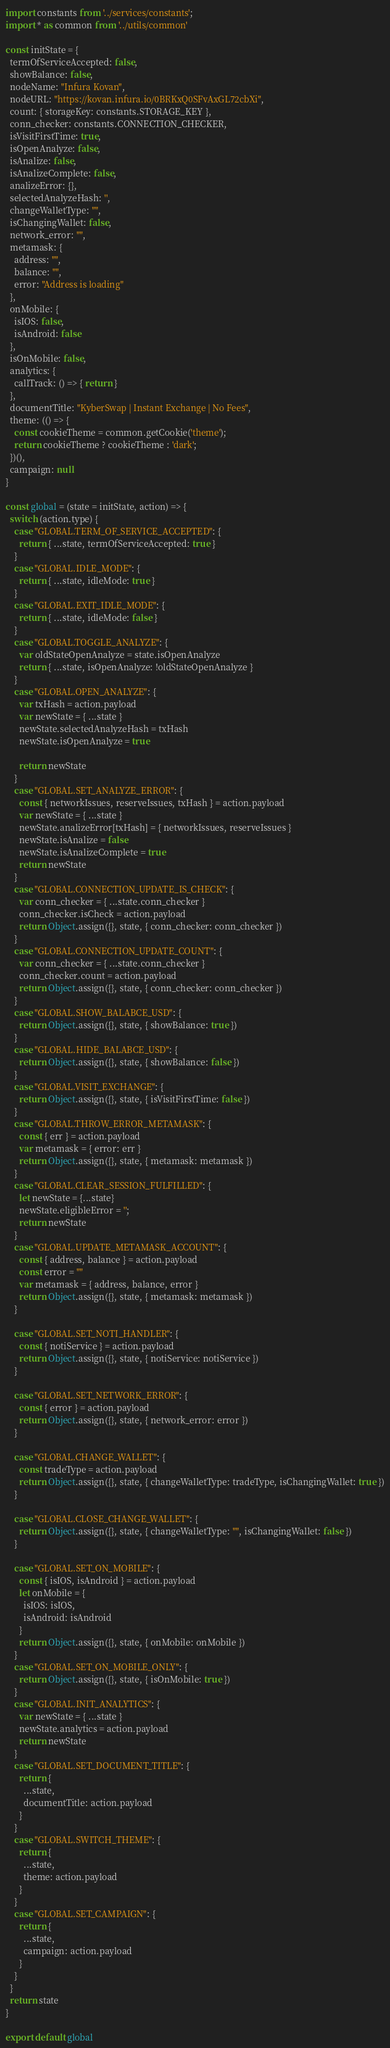<code> <loc_0><loc_0><loc_500><loc_500><_JavaScript_>import constants from '../services/constants';
import * as common from '../utils/common'

const initState = {
  termOfServiceAccepted: false,
  showBalance: false,
  nodeName: "Infura Kovan",
  nodeURL: "https://kovan.infura.io/0BRKxQ0SFvAxGL72cbXi",
  count: { storageKey: constants.STORAGE_KEY },
  conn_checker: constants.CONNECTION_CHECKER,
  isVisitFirstTime: true,
  isOpenAnalyze: false,
  isAnalize: false,
  isAnalizeComplete: false,
  analizeError: {},
  selectedAnalyzeHash: '',
  changeWalletType: "",
  isChangingWallet: false,
  network_error: "",
  metamask: {
    address: "",
    balance: "",
    error: "Address is loading"
  },
  onMobile: {
    isIOS: false,
    isAndroid: false
  },
  isOnMobile: false,
  analytics: {
    callTrack: () => { return }
  },
  documentTitle: "KyberSwap | Instant Exchange | No Fees",
  theme: (() => {
    const cookieTheme = common.getCookie('theme');
    return cookieTheme ? cookieTheme : 'dark';
  })(),
  campaign: null
}

const global = (state = initState, action) => {
  switch (action.type) {
    case "GLOBAL.TERM_OF_SERVICE_ACCEPTED": {
      return { ...state, termOfServiceAccepted: true }
    }
    case "GLOBAL.IDLE_MODE": {
      return { ...state, idleMode: true }
    }
    case "GLOBAL.EXIT_IDLE_MODE": {
      return { ...state, idleMode: false }
    }
    case "GLOBAL.TOGGLE_ANALYZE": {
      var oldStateOpenAnalyze = state.isOpenAnalyze
      return { ...state, isOpenAnalyze: !oldStateOpenAnalyze }
    }
    case "GLOBAL.OPEN_ANALYZE": {
      var txHash = action.payload
      var newState = { ...state }
      newState.selectedAnalyzeHash = txHash
      newState.isOpenAnalyze = true

      return newState
    }
    case "GLOBAL.SET_ANALYZE_ERROR": {
      const { networkIssues, reserveIssues, txHash } = action.payload
      var newState = { ...state }
      newState.analizeError[txHash] = { networkIssues, reserveIssues }
      newState.isAnalize = false
      newState.isAnalizeComplete = true
      return newState
    }
    case "GLOBAL.CONNECTION_UPDATE_IS_CHECK": {
      var conn_checker = { ...state.conn_checker }
      conn_checker.isCheck = action.payload
      return Object.assign({}, state, { conn_checker: conn_checker })
    }
    case "GLOBAL.CONNECTION_UPDATE_COUNT": {
      var conn_checker = { ...state.conn_checker }
      conn_checker.count = action.payload
      return Object.assign({}, state, { conn_checker: conn_checker })
    }
    case "GLOBAL.SHOW_BALABCE_USD": {
      return Object.assign({}, state, { showBalance: true })
    }
    case "GLOBAL.HIDE_BALABCE_USD": {
      return Object.assign({}, state, { showBalance: false })
    }
    case "GLOBAL.VISIT_EXCHANGE": {
      return Object.assign({}, state, { isVisitFirstTime: false })
    }
    case "GLOBAL.THROW_ERROR_METAMASK": {
      const { err } = action.payload
      var metamask = { error: err }
      return Object.assign({}, state, { metamask: metamask })
    }
    case "GLOBAL.CLEAR_SESSION_FULFILLED": {
      let newState = {...state}
      newState.eligibleError = '';
      return newState
    }
    case "GLOBAL.UPDATE_METAMASK_ACCOUNT": {
      const { address, balance } = action.payload
      const error = ""
      var metamask = { address, balance, error }
      return Object.assign({}, state, { metamask: metamask })
    }

    case "GLOBAL.SET_NOTI_HANDLER": {
      const { notiService } = action.payload
      return Object.assign({}, state, { notiService: notiService })
    }

    case "GLOBAL.SET_NETWORK_ERROR": {
      const { error } = action.payload
      return Object.assign({}, state, { network_error: error })
    }

    case "GLOBAL.CHANGE_WALLET": {
      const tradeType = action.payload
      return Object.assign({}, state, { changeWalletType: tradeType, isChangingWallet: true })
    }

    case "GLOBAL.CLOSE_CHANGE_WALLET": {
      return Object.assign({}, state, { changeWalletType: "", isChangingWallet: false })
    }

    case "GLOBAL.SET_ON_MOBILE": {
      const { isIOS, isAndroid } = action.payload
      let onMobile = {
        isIOS: isIOS,
        isAndroid: isAndroid
      }
      return Object.assign({}, state, { onMobile: onMobile })
    }
    case "GLOBAL.SET_ON_MOBILE_ONLY": {
      return Object.assign({}, state, { isOnMobile: true })
    }
    case "GLOBAL.INIT_ANALYTICS": {
      var newState = { ...state }
      newState.analytics = action.payload
      return newState
    }
    case "GLOBAL.SET_DOCUMENT_TITLE": {
      return {
        ...state,
        documentTitle: action.payload
      }
    }
    case "GLOBAL.SWITCH_THEME": {
      return {
        ...state,
        theme: action.payload
      }
    }
    case "GLOBAL.SET_CAMPAIGN": {
      return {
        ...state,
        campaign: action.payload
      }
    }
  }
  return state
}

export default global
</code> 